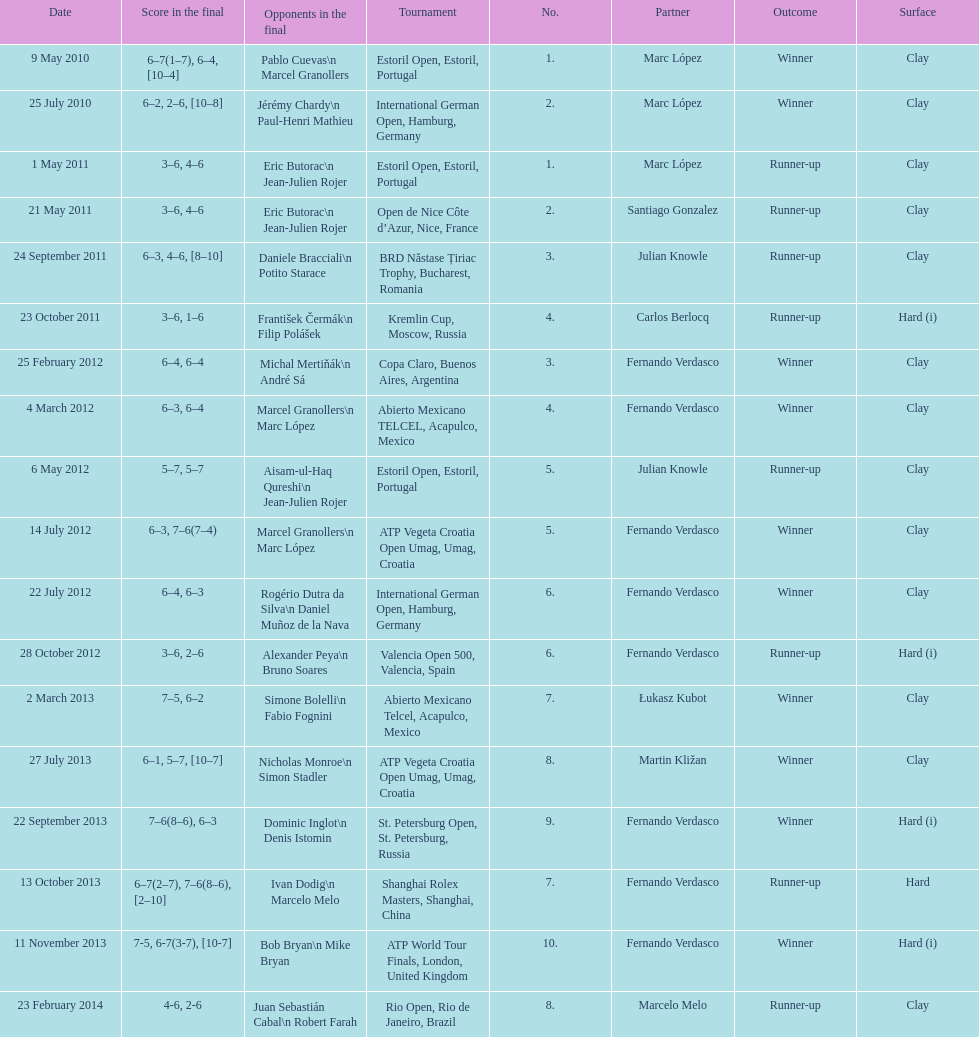What is the total number of runner-ups listed on the chart? 8. 